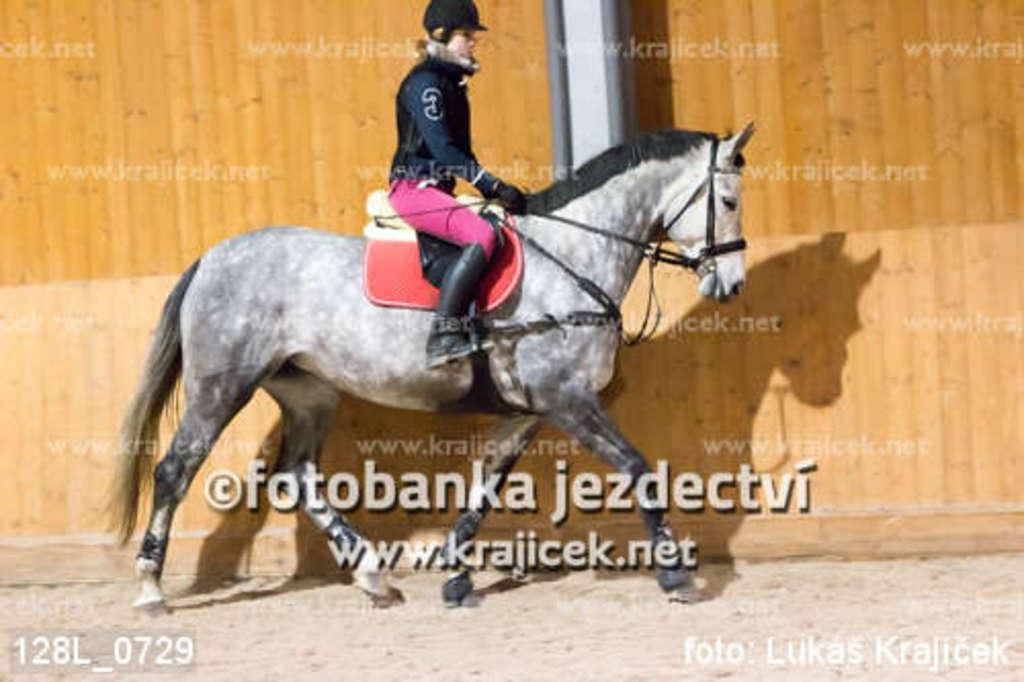What is happening in the foreground of the image? There is a person riding a horse in the foreground of the image. What can be seen on the ground in the foreground of the image? The ground is visible in the foreground of the image, and there is also sand present. What is written or displayed in the foreground of the image? There is text visible in the foreground of the image. What structures can be seen in the background of the image? There is a wall and a pillar in the background of the image. Can you describe the lighting conditions in the image? The image was likely taken during the day, as there is sufficient light to see the details clearly. What type of quince is being used by the doctor in the image? There is no doctor or quince present in the image; it features a person riding a horse in the foreground and a wall and pillar in the background. 